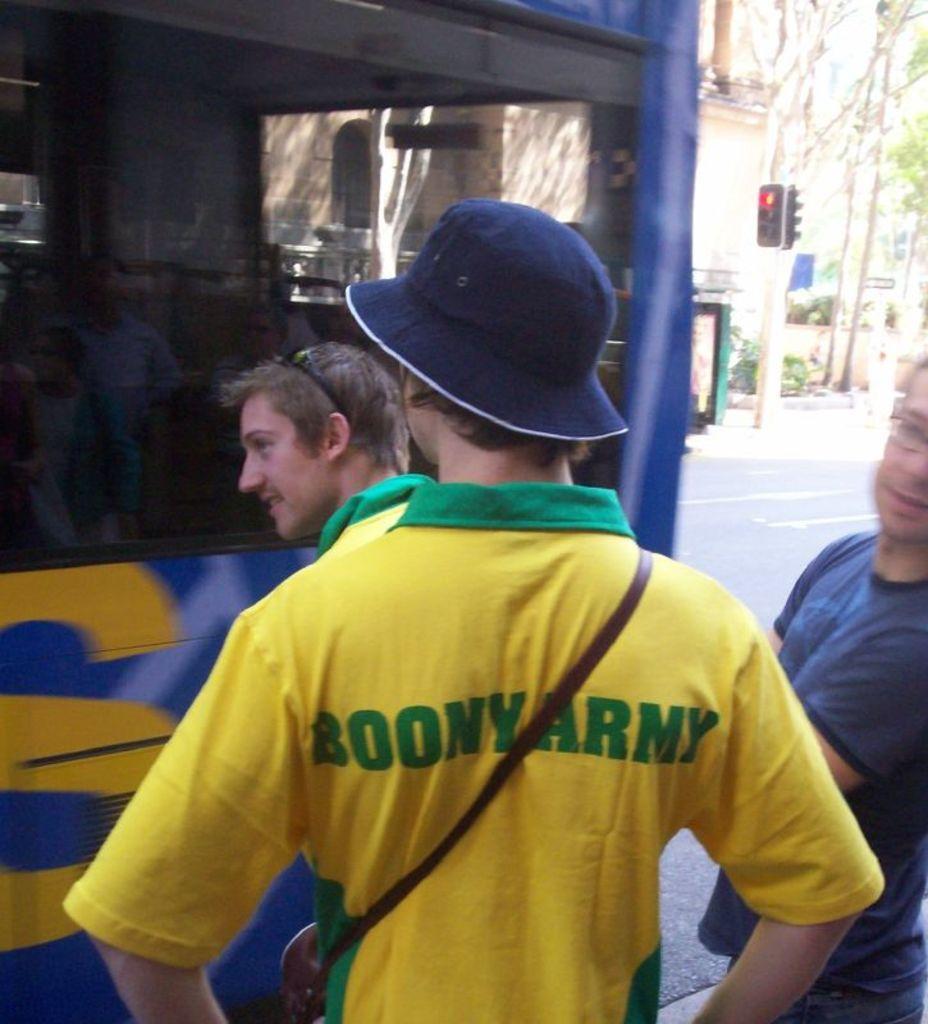Can you describe this image briefly? In this image in the foreground there are three people standing, and one person is wearing a hat. And in the background there is a bus, boards, traffic signals, trees and buildings. And at the bottom of the image there is road. 